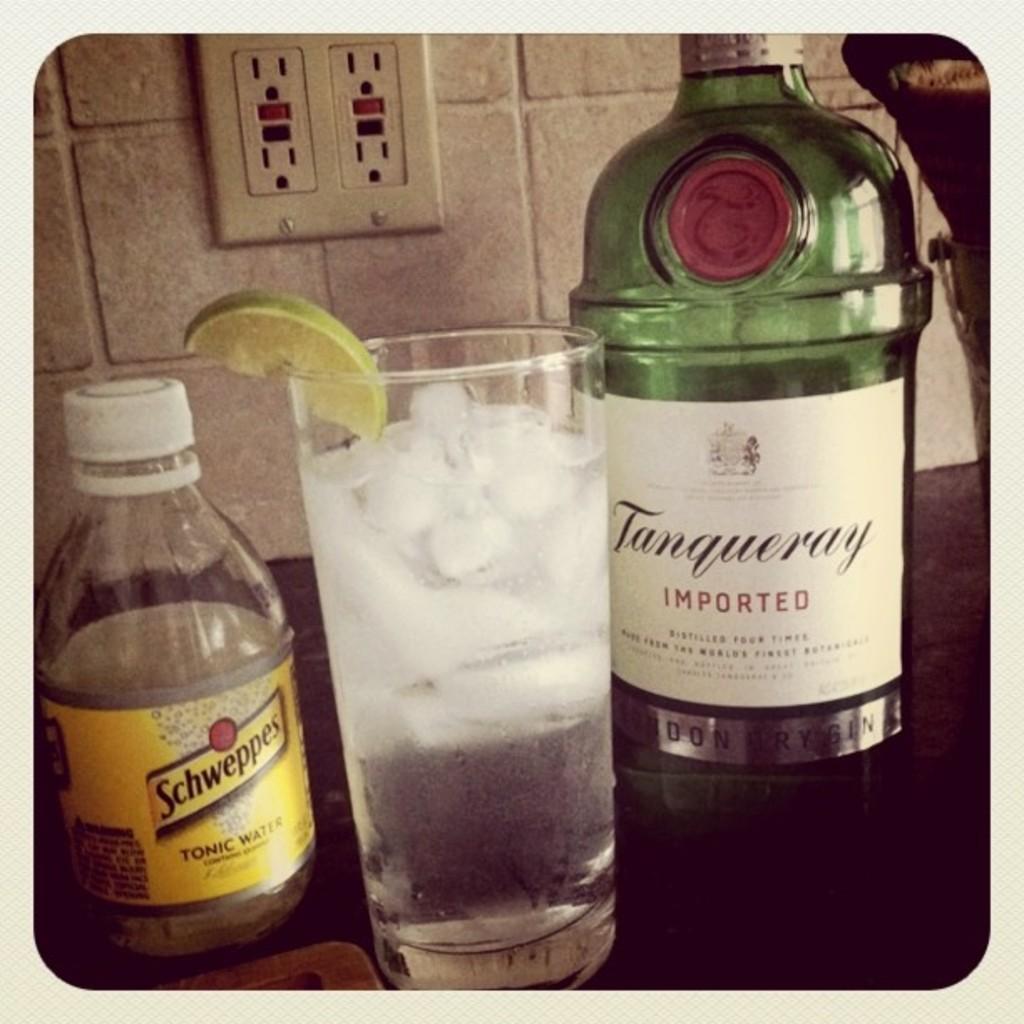What type of water is it?
Your answer should be compact. Tonic water. What´s the brand on the green bottle?
Make the answer very short. Tanqueray. 